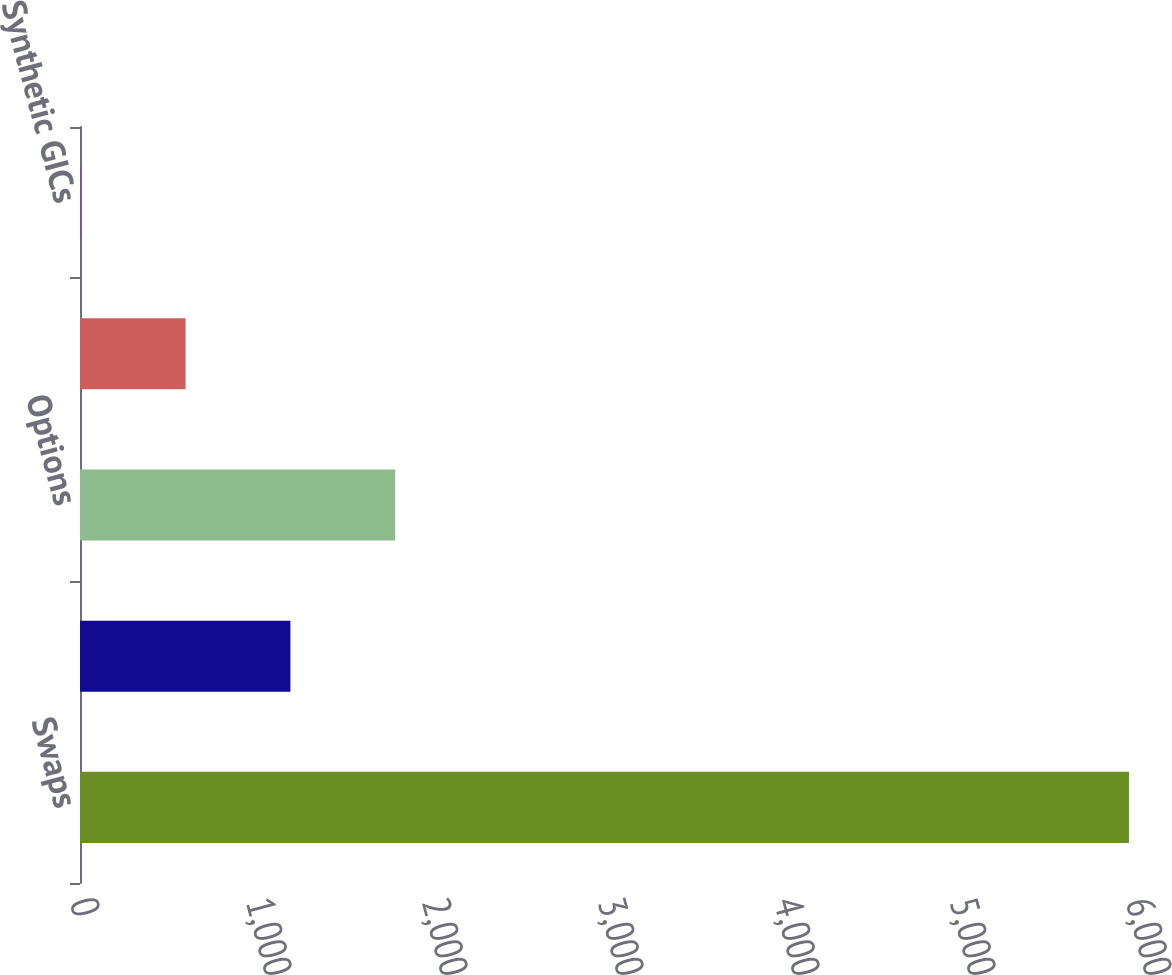Convert chart to OTSL. <chart><loc_0><loc_0><loc_500><loc_500><bar_chart><fcel>Swaps<fcel>Futures<fcel>Options<fcel>Forwards<fcel>Synthetic GICs<nl><fcel>5960<fcel>1195.45<fcel>1791.02<fcel>599.88<fcel>4.31<nl></chart> 